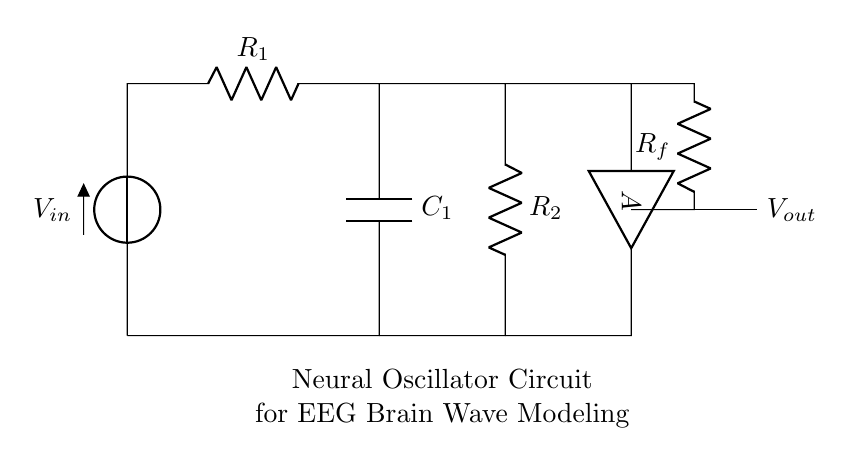What is the value of the input voltage? The input voltage is denoted as \( V_{in} \) in the circuit, and it is unspecified in the diagram.
Answer: \( V_{in} \) What types of components are present in the circuit? The components visible in the circuit include a voltage source, two resistors, a capacitor, and an operational amplifier, which are all labeled appropriately in the diagram.
Answer: Voltage source, resistors, capacitor, operational amplifier How many resistors are used in the circuit? The circuit contains three resistors: \( R_1 \), \( R_2 \), and \( R_f \), each identified in the diagram.
Answer: Three What role does the operational amplifier play in this circuit? The operational amplifier, labeled as \( A \), amplifies the output signal, which plays a crucial role in the oscillator function by introducing gain to the circuit, essential for generating oscillations.
Answer: Amplification What is the purpose of the capacitor in the oscillator circuit? The capacitor, labeled as \( C_1 \), stores electrical energy and contributes to the oscillatory behavior by creating a phase difference between charge and discharge cycles, which enables oscillations over time.
Answer: Energy storage and phase shift What defines this circuit as an oscillator circuit? An oscillator circuit is characterized by its ability to generate a continuous oscillating output, which is achieved here through the combination of resistors, capacitors, and an operational amplifier designed specifically for this purpose, ensuring sustained oscillations.
Answer: Continuous oscillating output 